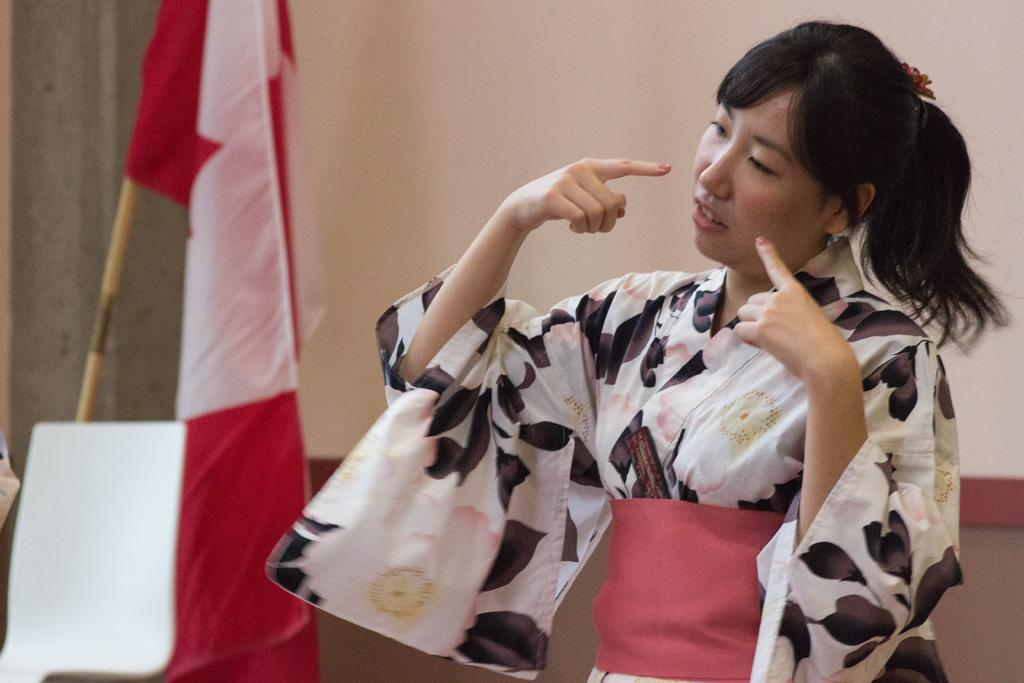Who is present in the image? There is a woman in the image. What is the woman wearing? The woman is wearing a white dress. What can be seen in the background of the image? There is a flag and a projector screen in the background of the image. Where is the chair located in the image? The chair is near the door in the bottom left corner of the image. What type of drug is the woman holding in the image? There is no drug present in the image; the woman is wearing a white dress and there are no objects in her hands. 